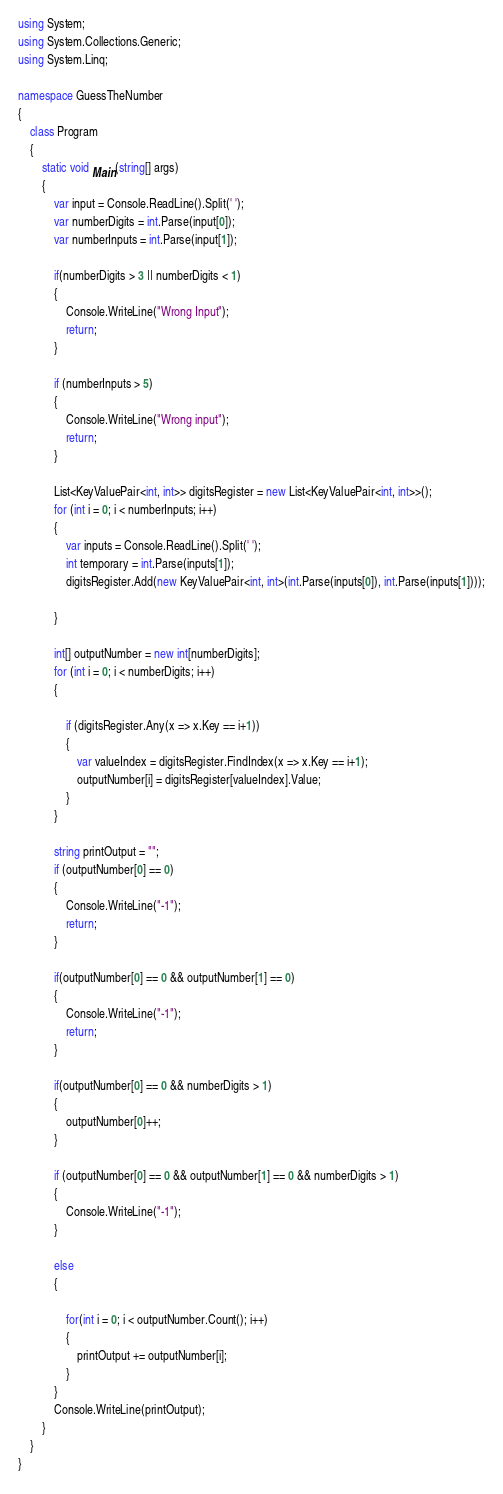Convert code to text. <code><loc_0><loc_0><loc_500><loc_500><_C#_>using System;
using System.Collections.Generic;
using System.Linq;

namespace GuessTheNumber
{
    class Program
    {
        static void Main(string[] args)
        {
            var input = Console.ReadLine().Split(' ');
            var numberDigits = int.Parse(input[0]);
            var numberInputs = int.Parse(input[1]);

            if(numberDigits > 3 || numberDigits < 1)
            {
                Console.WriteLine("Wrong Input");
                return;
            }

            if (numberInputs > 5)
            {
                Console.WriteLine("Wrong input");
                return;
            }

            List<KeyValuePair<int, int>> digitsRegister = new List<KeyValuePair<int, int>>();
            for (int i = 0; i < numberInputs; i++)
            {
                var inputs = Console.ReadLine().Split(' ');
                int temporary = int.Parse(inputs[1]);
                digitsRegister.Add(new KeyValuePair<int, int>(int.Parse(inputs[0]), int.Parse(inputs[1])));

            }

            int[] outputNumber = new int[numberDigits];
            for (int i = 0; i < numberDigits; i++)
            {
                
                if (digitsRegister.Any(x => x.Key == i+1))
                {
                    var valueIndex = digitsRegister.FindIndex(x => x.Key == i+1);
                    outputNumber[i] = digitsRegister[valueIndex].Value;
                }
            }

            string printOutput = "";
            if (outputNumber[0] == 0)
            {
                Console.WriteLine("-1");
                return;
            }

            if(outputNumber[0] == 0 && outputNumber[1] == 0)
            {
                Console.WriteLine("-1");
                return;
            }

            if(outputNumber[0] == 0 && numberDigits > 1)
            {
                outputNumber[0]++;
            }

            if (outputNumber[0] == 0 && outputNumber[1] == 0 && numberDigits > 1)
            {
                Console.WriteLine("-1");
            }

            else
            {
                
                for(int i = 0; i < outputNumber.Count(); i++)
                {
                    printOutput += outputNumber[i];
                }
            }
            Console.WriteLine(printOutput);
        }
    }
}
</code> 